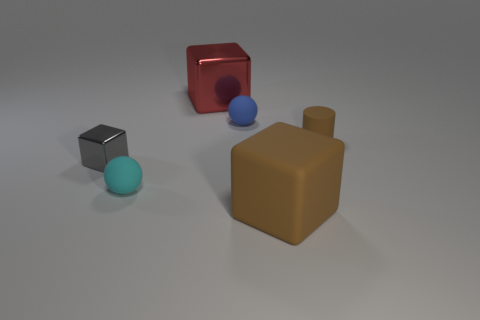Add 2 small cyan rubber things. How many objects exist? 8 Subtract all balls. How many objects are left? 4 Subtract all blue spheres. How many spheres are left? 1 Subtract all red metallic blocks. How many blocks are left? 2 Subtract all large cyan rubber spheres. Subtract all tiny things. How many objects are left? 2 Add 1 cyan things. How many cyan things are left? 2 Add 6 shiny things. How many shiny things exist? 8 Subtract 0 green cubes. How many objects are left? 6 Subtract 1 cubes. How many cubes are left? 2 Subtract all gray balls. Subtract all yellow blocks. How many balls are left? 2 